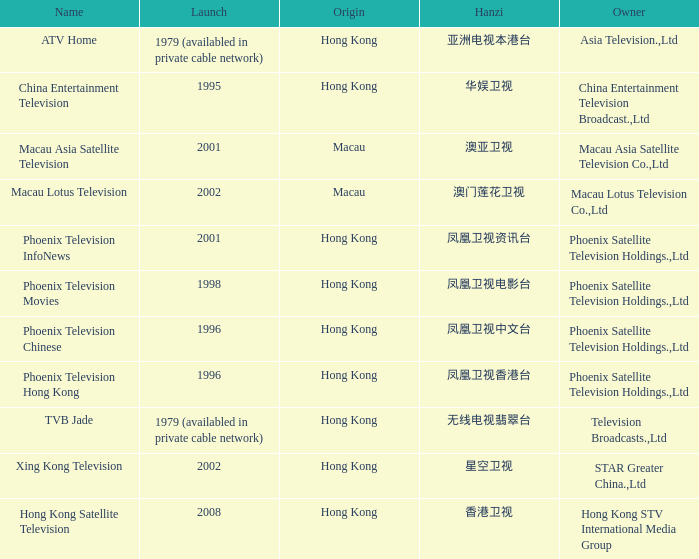What is the Hanzi of Phoenix Television Chinese that launched in 1996? 凤凰卫视中文台. 